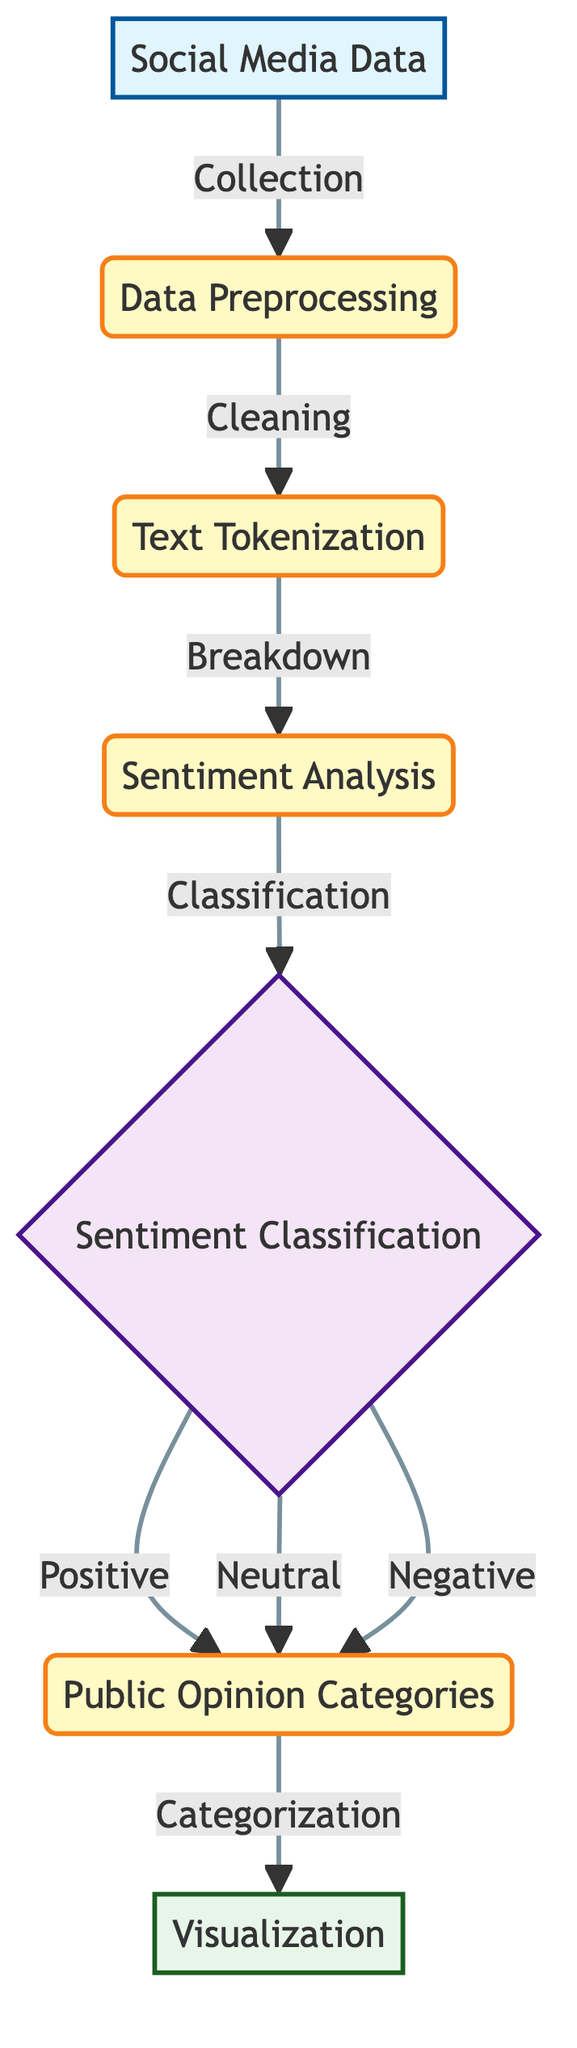What is the first step in the diagram? The diagram indicates that the first step involves the collection of data from social media, which is represented by the node labeled "Social Media Data".
Answer: Collection How many nodes are present in the diagram? Counting all the distinct nodes shown, including input, process, decision, and output nodes, there are a total of 7 nodes in the flowchart.
Answer: 7 What type of classification occurs after the sentiment analysis? After conducting sentiment analysis, the diagram shows that the next step involves classifying the sentiment into categories: Positive, Neutral, and Negative.
Answer: Sentiment Classification What are the output categories based on sentiment classification? The output categories displayed in the diagram all fall under the node titled "Public Opinion Categories" and include Positive, Neutral, and Negative sentiments.
Answer: Public Opinion Categories Which node represents data cleaning? The node labeled "Cleaning" directly follows the "Data Preprocessing" node and represents the data cleaning process before text tokenization occurs.
Answer: Cleaning What is the role of the node labeled "Visualization"? The "Visualization" node is the terminal output of the process, summarizing the categorized public opinion into a visual format to help interpret the results of the sentiment analysis.
Answer: Visualization How does data transition from sentiment analysis to categorization? Data transitions from "Sentiment Analysis" to "Categorization" through the classification into Positive, Neutral, or Negative. Each of these classifications leads back to the same "Public Opinion Categories" node before moving on to visualization.
Answer: Through classification What distinguishes the decision node from other nodes in the diagram? The decision node, represented by "Sentiment Classification," is unique as it requires categorization based on the output from the sentiment analysis, whereas other nodes are either input or process nodes without decision-making criteria.
Answer: Sentiment Classification 